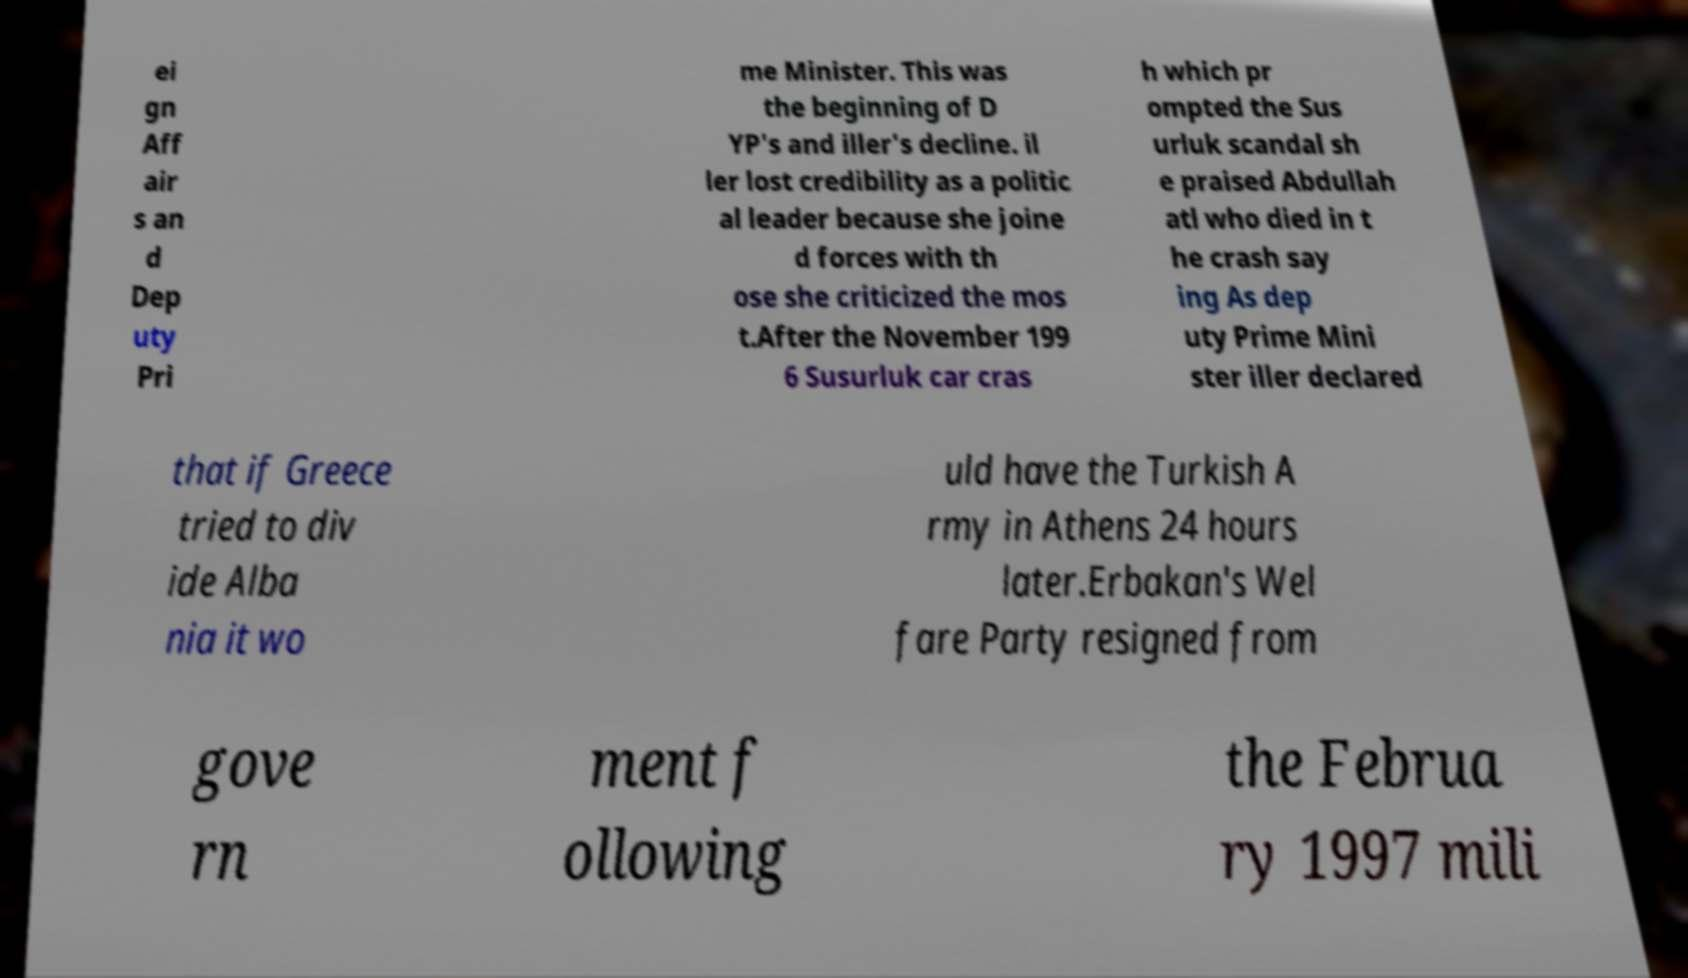There's text embedded in this image that I need extracted. Can you transcribe it verbatim? ei gn Aff air s an d Dep uty Pri me Minister. This was the beginning of D YP's and iller's decline. il ler lost credibility as a politic al leader because she joine d forces with th ose she criticized the mos t.After the November 199 6 Susurluk car cras h which pr ompted the Sus urluk scandal sh e praised Abdullah atl who died in t he crash say ing As dep uty Prime Mini ster iller declared that if Greece tried to div ide Alba nia it wo uld have the Turkish A rmy in Athens 24 hours later.Erbakan's Wel fare Party resigned from gove rn ment f ollowing the Februa ry 1997 mili 